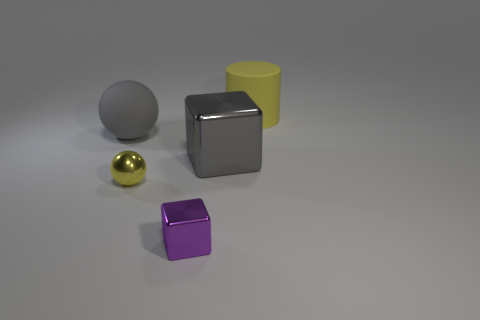Can you tell me which objects in the picture have a matte finish? Certainly! In the image provided, the matte finish is observed on the grey ball and the yellow cylinder. These objects display a non-reflective surface, which implies a matte texture. 